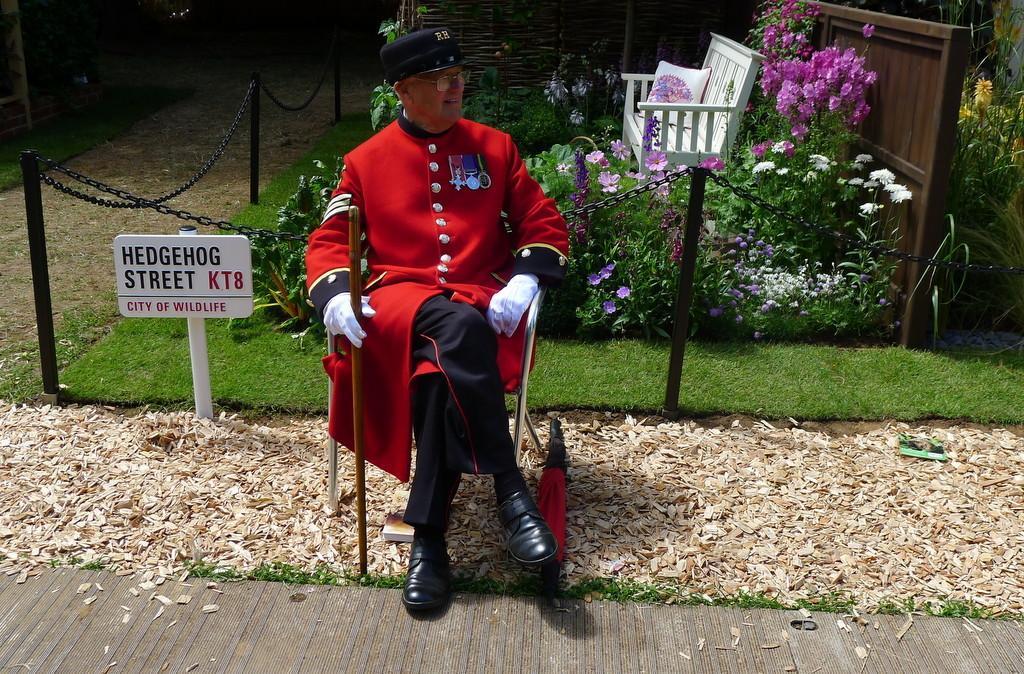Can you describe this image briefly? In this picture we can see a man is sitting on a chair and holding a stick, at the bottom there is sawdust, on the left side we can see a board, in the background there are some plants, flowers, grass and a bench, there is a pillow on the bench. 